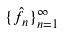<formula> <loc_0><loc_0><loc_500><loc_500>\{ \hat { f } _ { n } \} _ { n = 1 } ^ { \infty }</formula> 